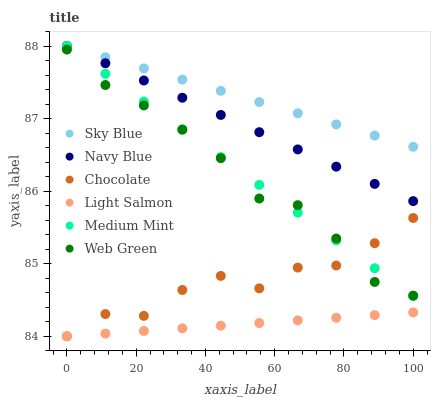Does Light Salmon have the minimum area under the curve?
Answer yes or no. Yes. Does Sky Blue have the maximum area under the curve?
Answer yes or no. Yes. Does Navy Blue have the minimum area under the curve?
Answer yes or no. No. Does Navy Blue have the maximum area under the curve?
Answer yes or no. No. Is Sky Blue the smoothest?
Answer yes or no. Yes. Is Chocolate the roughest?
Answer yes or no. Yes. Is Light Salmon the smoothest?
Answer yes or no. No. Is Light Salmon the roughest?
Answer yes or no. No. Does Light Salmon have the lowest value?
Answer yes or no. Yes. Does Navy Blue have the lowest value?
Answer yes or no. No. Does Sky Blue have the highest value?
Answer yes or no. Yes. Does Light Salmon have the highest value?
Answer yes or no. No. Is Light Salmon less than Web Green?
Answer yes or no. Yes. Is Navy Blue greater than Light Salmon?
Answer yes or no. Yes. Does Medium Mint intersect Chocolate?
Answer yes or no. Yes. Is Medium Mint less than Chocolate?
Answer yes or no. No. Is Medium Mint greater than Chocolate?
Answer yes or no. No. Does Light Salmon intersect Web Green?
Answer yes or no. No. 